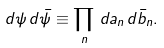<formula> <loc_0><loc_0><loc_500><loc_500>d \psi \, d \bar { \psi } \equiv \prod _ { n } \, d a _ { n } \, d \bar { b } _ { n } .</formula> 